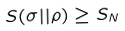Convert formula to latex. <formula><loc_0><loc_0><loc_500><loc_500>S ( \sigma | | \rho ) \geq S _ { N }</formula> 